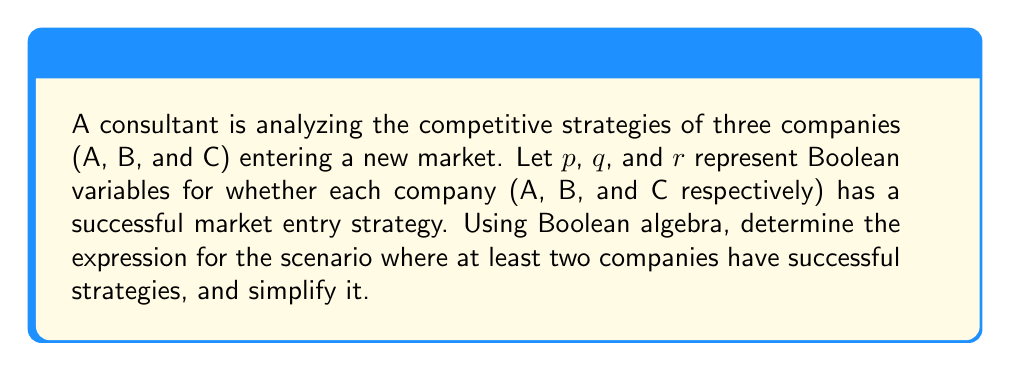Help me with this question. To solve this problem, we'll follow these steps:

1) First, let's define the Boolean expression for at least two companies having successful strategies. This can be represented as:

   $$(p \land q) \lor (p \land r) \lor (q \land r)$$

2) We can simplify this expression using Boolean algebra laws:

   a) Distributive law: $a \land (b \lor c) = (a \land b) \lor (a \land c)$
   
   b) Commutative law: $a \lor b = b \lor a$
   
   c) Idempotent law: $a \lor a = a$

3) Let's apply the distributive law:

   $$(p \land q) \lor (p \land r) \lor (q \land r)$$
   $$= p \land (q \lor r) \lor (q \land r)$$

4) Now, let's apply the distributive law again:

   $$= (p \land q) \lor (p \land r) \lor (q \land r)$$

5) This is the same as our original expression, which means it's already in its simplest form.

6) However, we can also represent this using the majority function:

   $$\text{majority}(p,q,r) = (p \land q) \lor (p \land r) \lor (q \land r)$$

This simplified expression represents the scenario where at least two out of the three companies have successful market entry strategies.
Answer: $(p \land q) \lor (p \land r) \lor (q \land r)$ 